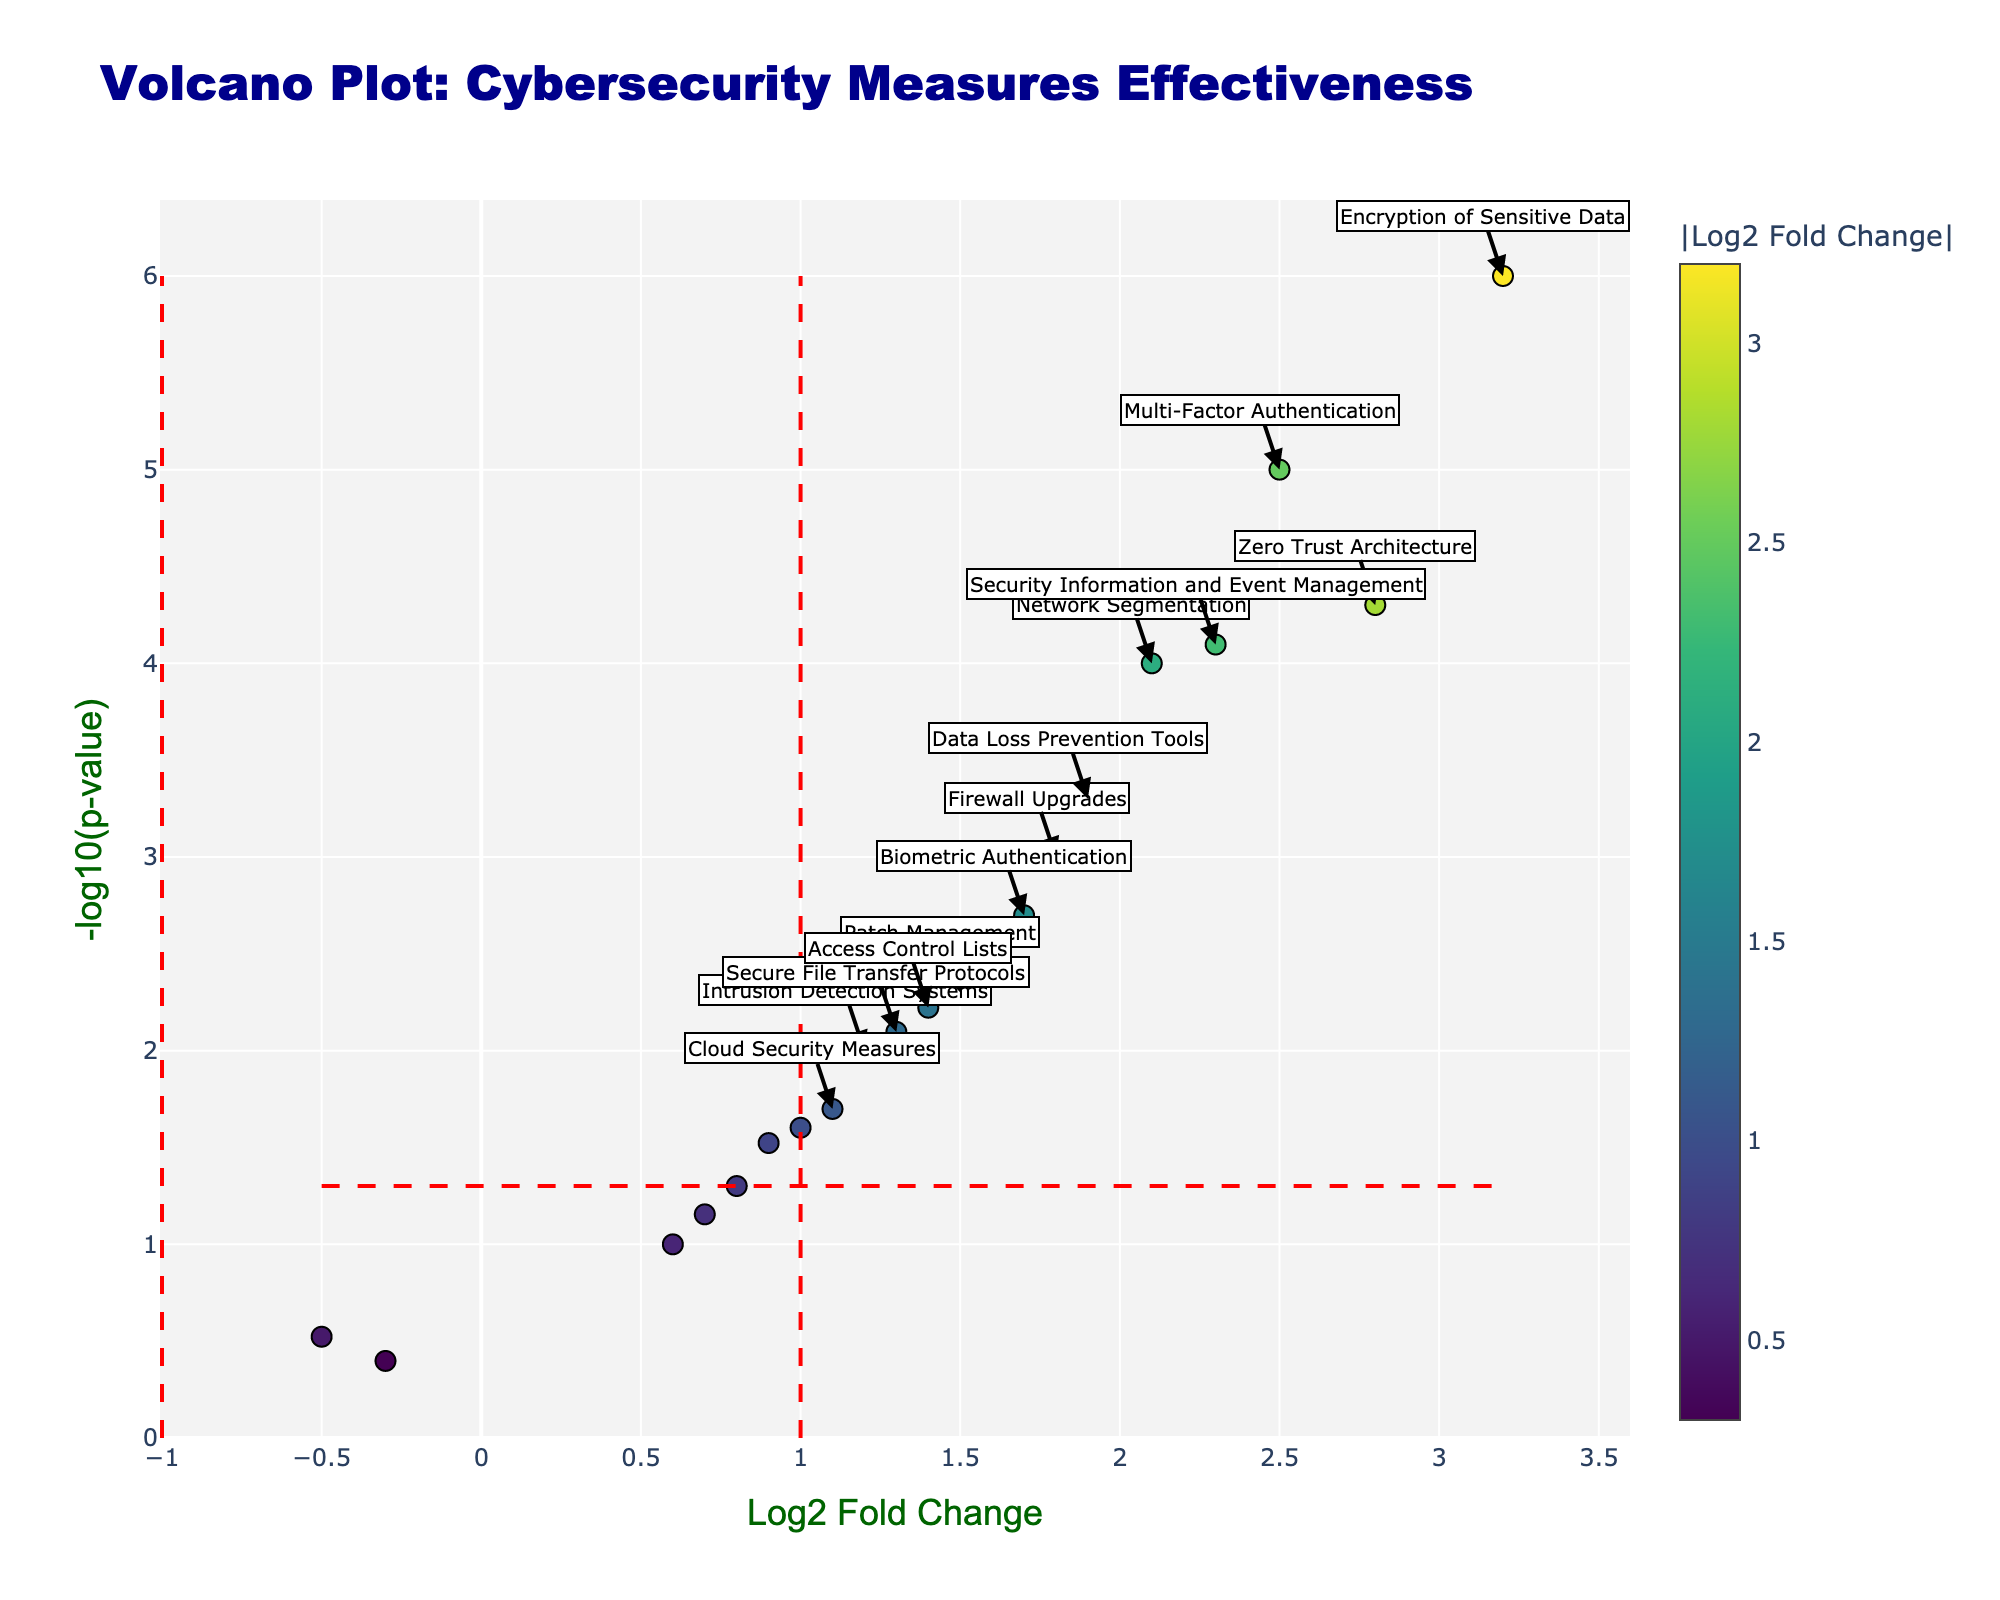What is the title of the plot? The title is usually located at the top of the figure in a larger font. In this plot, the title is 'Volcano Plot: Cybersecurity Measures Effectiveness'.
Answer: Volcano Plot: Cybersecurity Measures Effectiveness What does the x-axis represent? The x-axis label is typically found beneath the x-axis line and indicates what the plotted data measures. In this case, the x-axis represents 'Log2 Fold Change'.
Answer: Log2 Fold Change Which measure has the highest Log2 Fold Change? By examining the x-axis for the highest value, we find that 'Encryption of Sensitive Data' has the highest Log2 Fold Change value at 3.2.
Answer: Encryption of Sensitive Data How many measures are significantly effective (above the p-value and fold-change thresholds)? Significantly effective measures are those with an absolute Log2 Fold Change greater than 1 and a p-value less than 0.05. By counting the annotated points above both thresholds, we find 10 such measures.
Answer: 10 What is the p-value threshold used in the plot? The red horizontal line indicates the p-value threshold, which corresponds to a -log10(p-value). This threshold is often a common significance level used, here it is 0.05, so -log10(0.05) ≈ 1.3.
Answer: 0.05 Which measure has the smallest p-value? The smallest p-value will be visually identified as having the highest -log10(p-value) value. 'Encryption of Sensitive Data' has the highest -log10(p-value), corresponding to the smallest p-value of 0.000001.
Answer: Encryption of Sensitive Data Is 'Employee Training Programs' considered effective based on the thresholds? 'Employee Training Programs' has a Log2 Fold Change of -0.5 and a p-value of 0.3. Neither value passes the thresholds for effectiveness (absolute Log2 Fold Change > 1 and p-value < 0.05).
Answer: No Compare the Log2 Fold Change of 'Network Segmentation' and 'Firewall Upgrades'. Which is higher? The Log2 Fold Change for 'Network Segmentation' is 2.1, while for 'Firewall Upgrades' it is 1.8. Hence, 'Network Segmentation' has a higher Log2 Fold Change.
Answer: Network Segmentation What general trend can you observe in terms of measure efficacy and Log2 Fold Change? Observing overall trends, higher Log2 Fold Change values are associated with smaller p-values, indicating more significant cybersecurity measures. The top effective measures all show strong fold changes.
Answer: Higher Log2 Fold Change values indicate more effective measures 